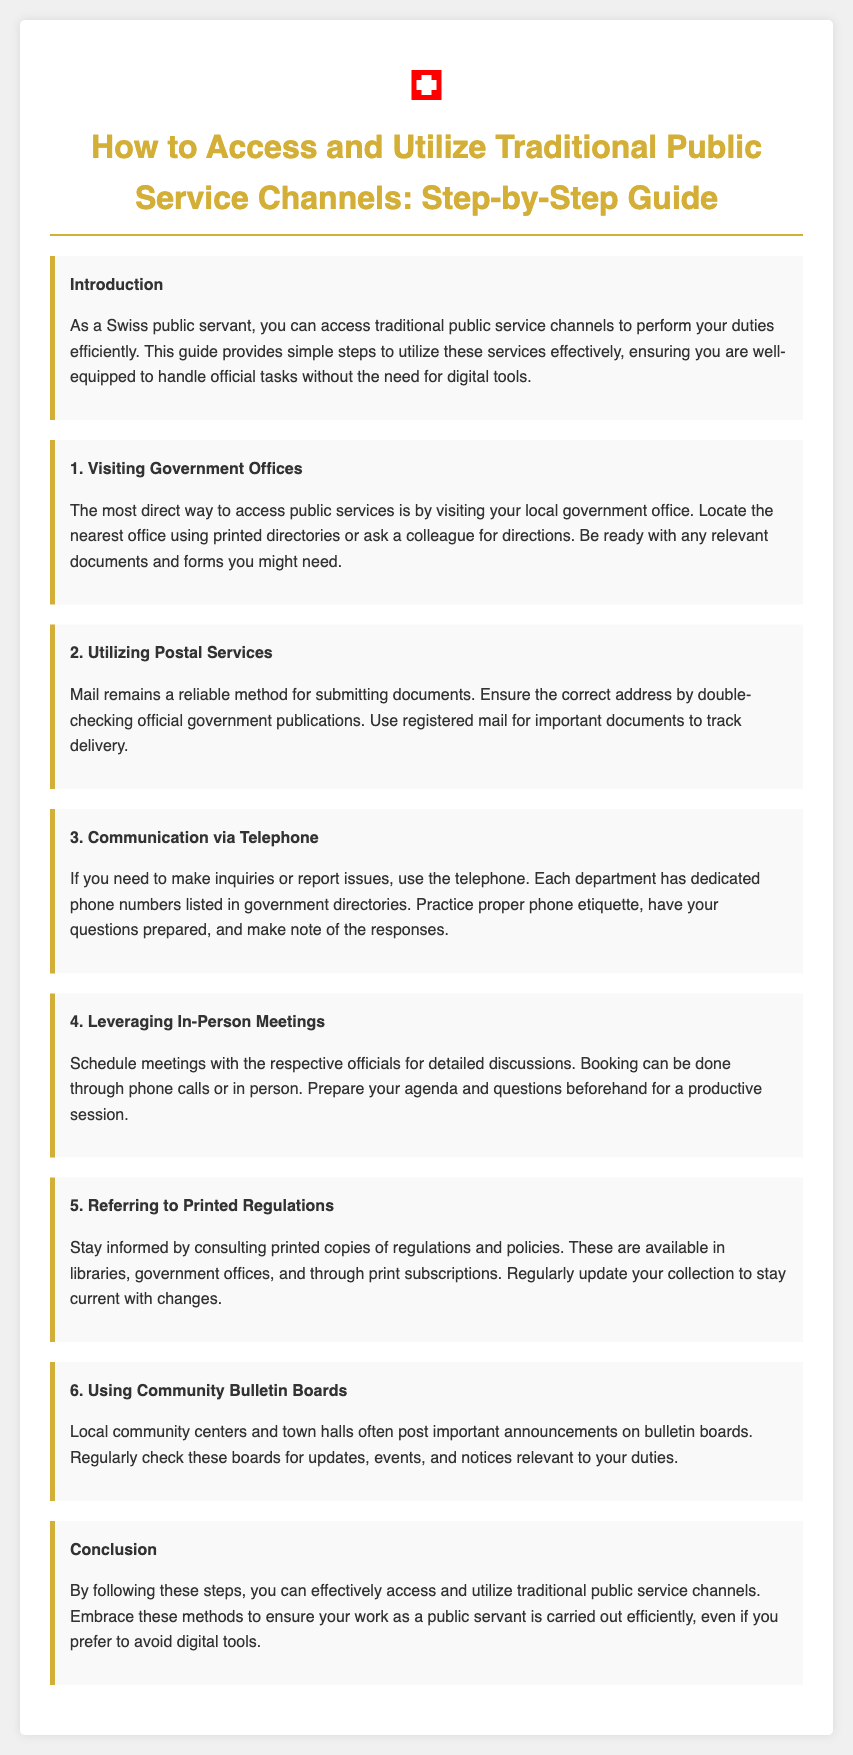what is the title of the guide? The title appears at the top of the document and provides the main subject.
Answer: How to Access and Utilize Traditional Public Service Channels: Step-by-Step Guide what method is suggested for submitting documents? The document lists a specific method in the section about postal services.
Answer: Utilizing Postal Services how can you prepare for an inquiry via telephone? The document mentions preparation for making inquiries, specifically regarding phone inquiries.
Answer: Have your questions prepared where can printed regulations be found? The document states locations for consulting printed regulations.
Answer: Libraries, government offices, and through print subscriptions what is the first step to access public services? The introduction outlines the steps to access public service channels, highlighting the most direct way first.
Answer: Visiting Government Offices what should you do for in-person meetings? The section on leveraging in-person meetings outlines important preparatory actions.
Answer: Prepare your agenda and questions beforehand what are community bulletin boards used for? The document describes the purpose of community bulletin boards in a specific section.
Answer: Important announcements how should important documents be mailed? The section about postal services specifies the best practice for important document submissions.
Answer: Use registered mail 